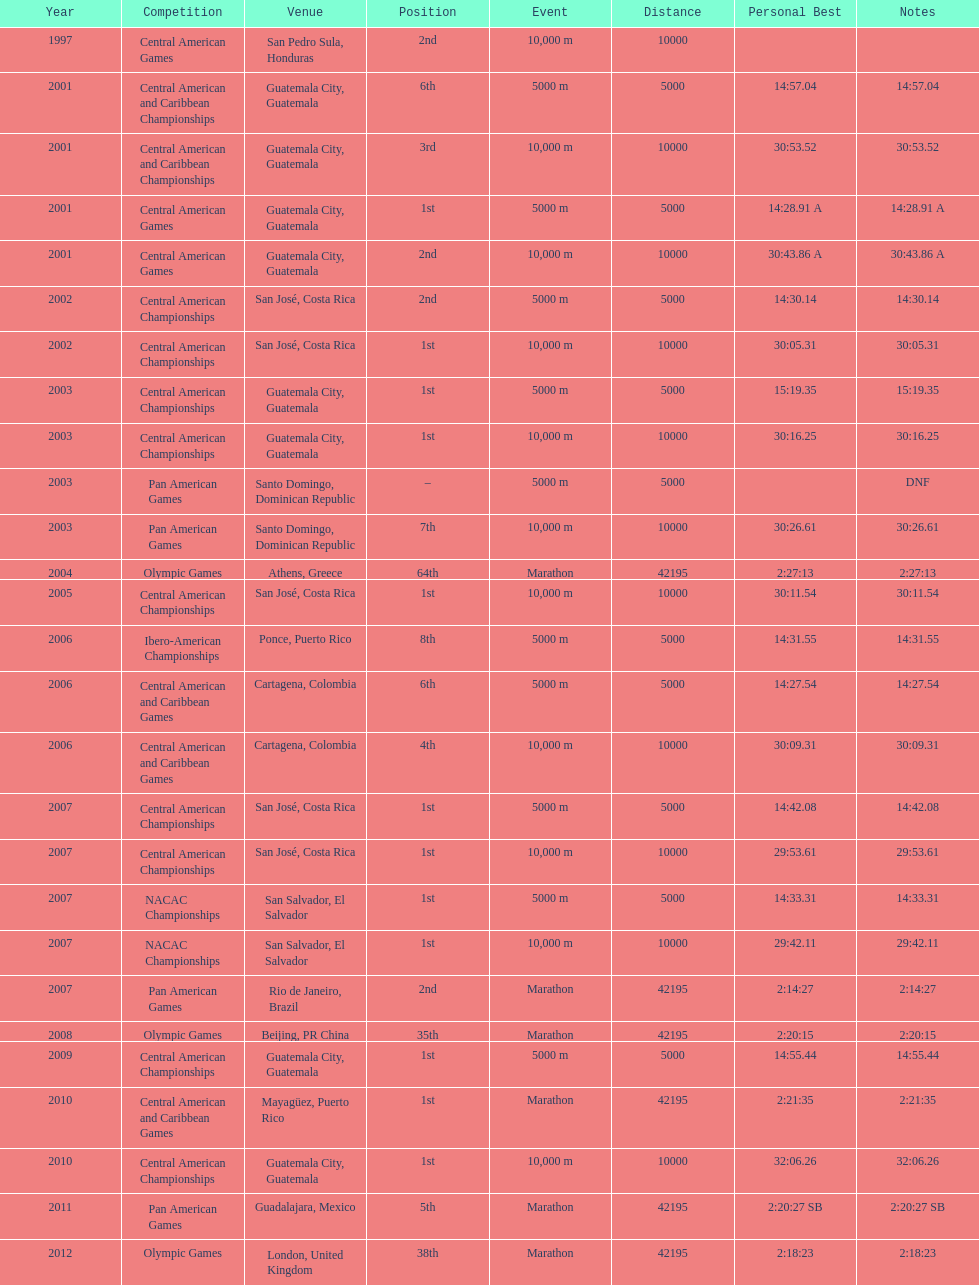What was the last competition in which a position of "2nd" was achieved? Pan American Games. 